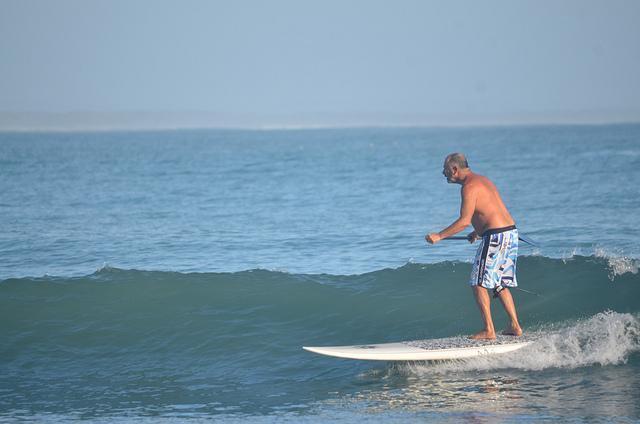How many people are on that surfboard?
Give a very brief answer. 1. How many different colors of umbrellas can be seen?
Give a very brief answer. 0. 